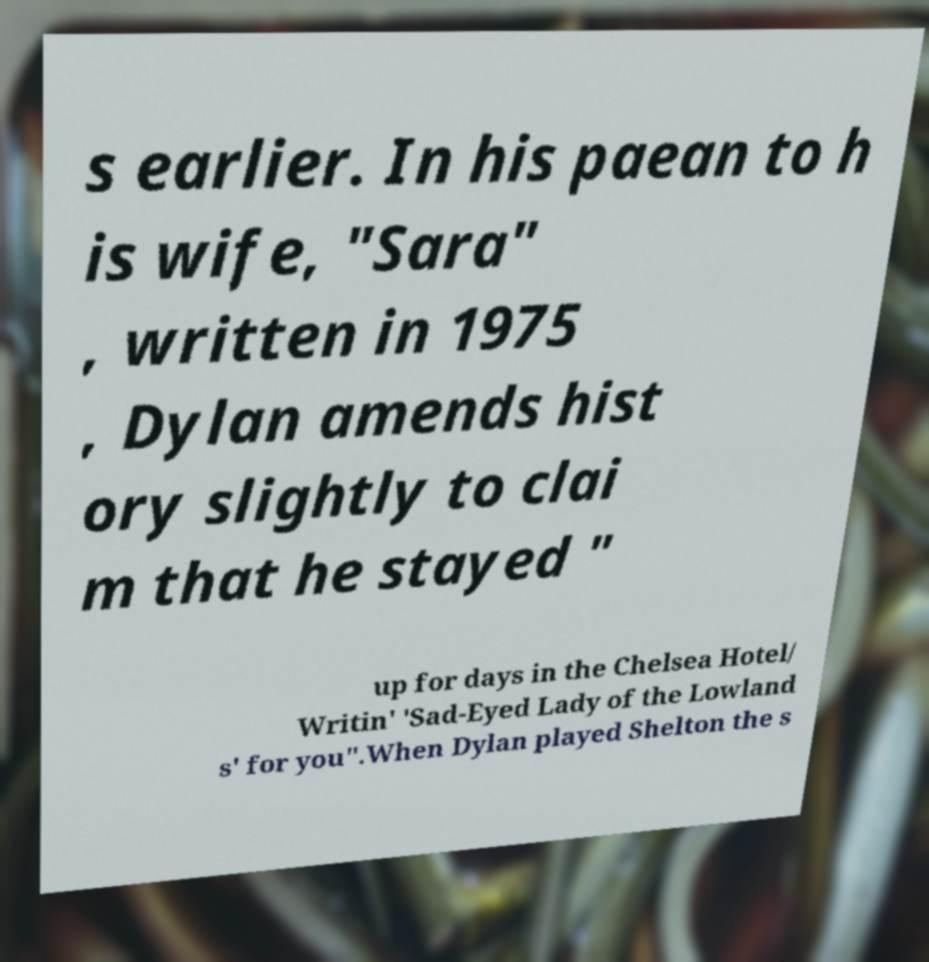What messages or text are displayed in this image? I need them in a readable, typed format. s earlier. In his paean to h is wife, "Sara" , written in 1975 , Dylan amends hist ory slightly to clai m that he stayed " up for days in the Chelsea Hotel/ Writin' 'Sad-Eyed Lady of the Lowland s' for you".When Dylan played Shelton the s 